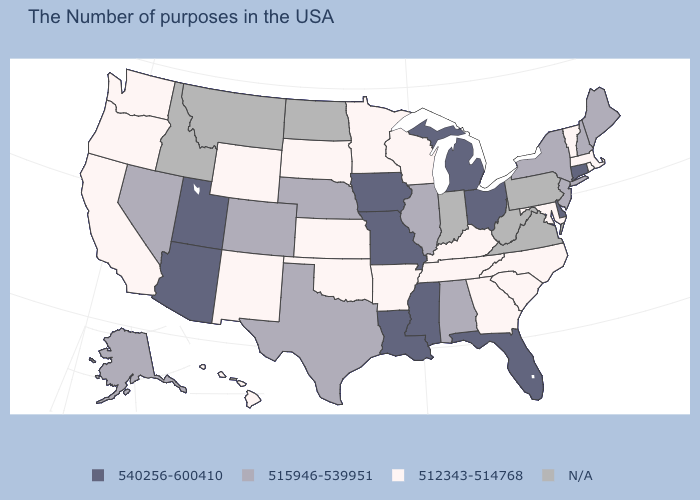What is the highest value in states that border Rhode Island?
Give a very brief answer. 540256-600410. Which states have the lowest value in the USA?
Be succinct. Massachusetts, Rhode Island, Vermont, Maryland, North Carolina, South Carolina, Georgia, Kentucky, Tennessee, Wisconsin, Arkansas, Minnesota, Kansas, Oklahoma, South Dakota, Wyoming, New Mexico, California, Washington, Oregon, Hawaii. Among the states that border Pennsylvania , which have the highest value?
Quick response, please. Delaware, Ohio. Does the first symbol in the legend represent the smallest category?
Be succinct. No. Among the states that border Missouri , which have the lowest value?
Answer briefly. Kentucky, Tennessee, Arkansas, Kansas, Oklahoma. Does Illinois have the lowest value in the USA?
Keep it brief. No. What is the highest value in the USA?
Keep it brief. 540256-600410. What is the highest value in states that border North Carolina?
Give a very brief answer. 512343-514768. What is the value of New York?
Answer briefly. 515946-539951. Name the states that have a value in the range 515946-539951?
Write a very short answer. Maine, New Hampshire, New York, New Jersey, Alabama, Illinois, Nebraska, Texas, Colorado, Nevada, Alaska. Name the states that have a value in the range 540256-600410?
Answer briefly. Connecticut, Delaware, Ohio, Florida, Michigan, Mississippi, Louisiana, Missouri, Iowa, Utah, Arizona. Does the first symbol in the legend represent the smallest category?
Concise answer only. No. Does the first symbol in the legend represent the smallest category?
Concise answer only. No. What is the value of Indiana?
Keep it brief. N/A. 